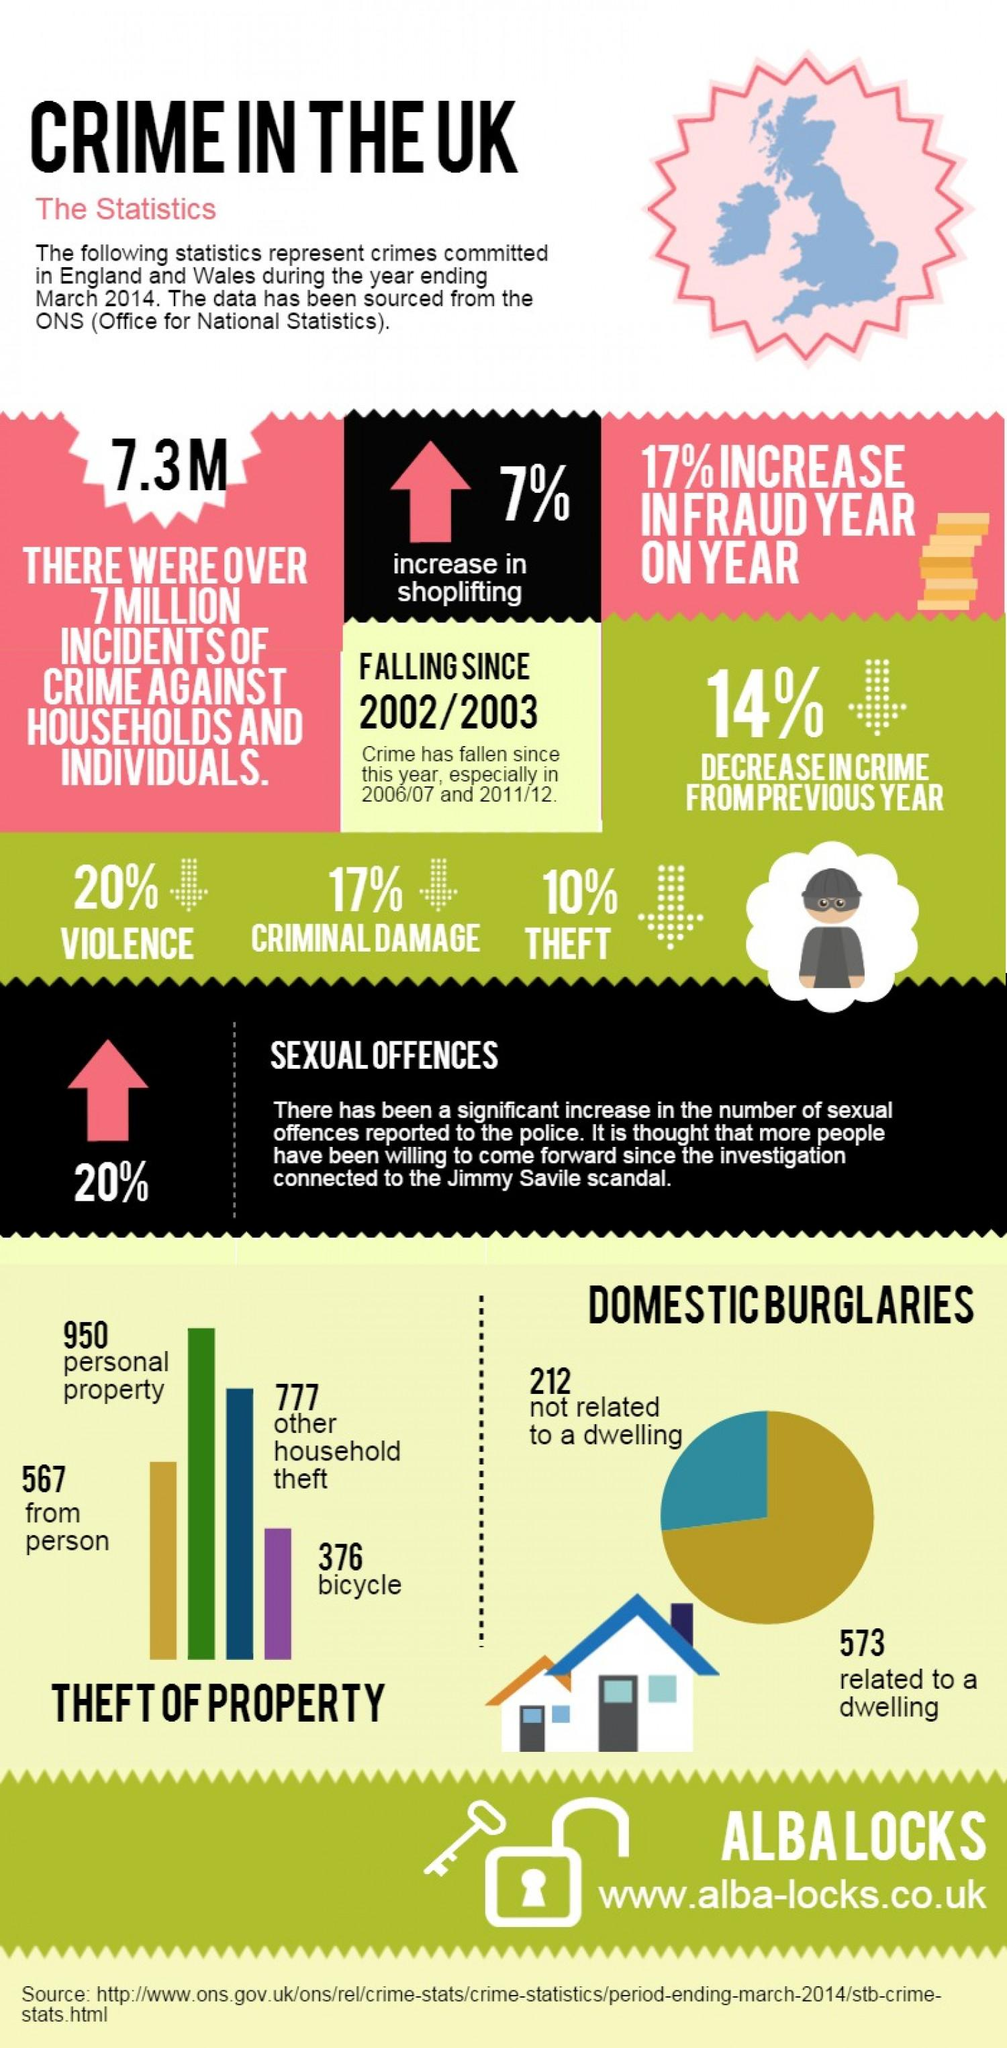Point out several critical features in this image. Of the reported property thefts, a significant number, approximately 567, were thefts from a person. The percentage decrease in criminal damage is 17%. The percentage increase in fraud year on year is 17%. 